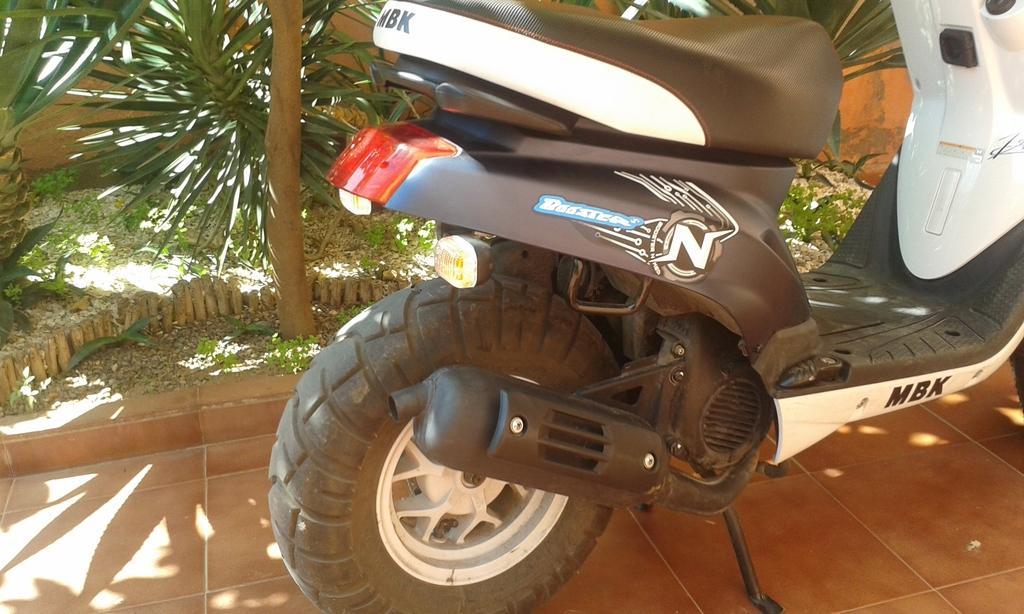Please provide a concise description of this image. This image consists of a vehicle parked. At the bottom, there is a floor. In the background, there are plants. 